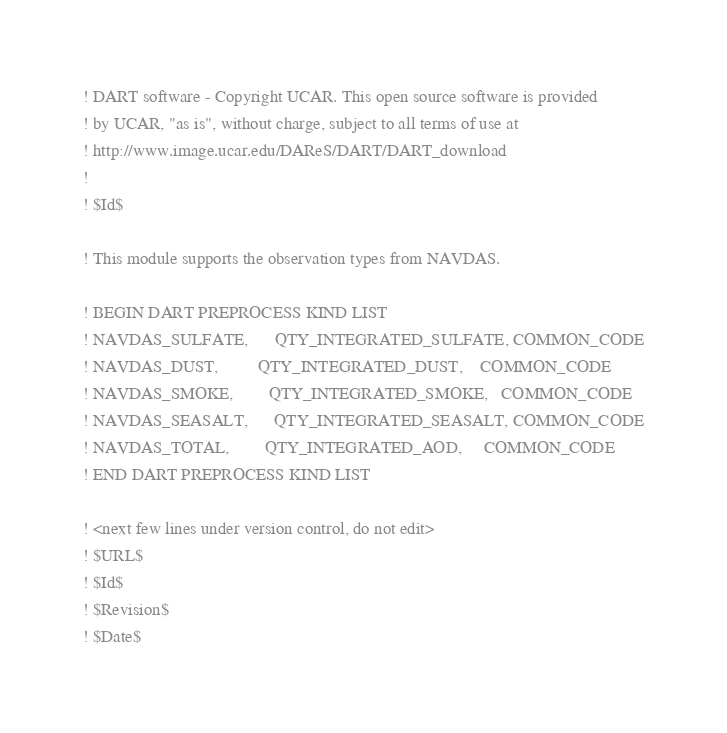Convert code to text. <code><loc_0><loc_0><loc_500><loc_500><_FORTRAN_>! DART software - Copyright UCAR. This open source software is provided
! by UCAR, "as is", without charge, subject to all terms of use at
! http://www.image.ucar.edu/DAReS/DART/DART_download
!
! $Id$

! This module supports the observation types from NAVDAS.

! BEGIN DART PREPROCESS KIND LIST
! NAVDAS_SULFATE,      QTY_INTEGRATED_SULFATE, COMMON_CODE
! NAVDAS_DUST,         QTY_INTEGRATED_DUST,    COMMON_CODE
! NAVDAS_SMOKE,        QTY_INTEGRATED_SMOKE,   COMMON_CODE
! NAVDAS_SEASALT,      QTY_INTEGRATED_SEASALT, COMMON_CODE
! NAVDAS_TOTAL,        QTY_INTEGRATED_AOD,     COMMON_CODE
! END DART PREPROCESS KIND LIST

! <next few lines under version control, do not edit>
! $URL$
! $Id$
! $Revision$
! $Date$
</code> 